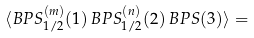<formula> <loc_0><loc_0><loc_500><loc_500>\langle B P S _ { 1 / 2 } ^ { ( m ) } ( 1 ) \, B P S _ { 1 / 2 } ^ { ( n ) } ( 2 ) \, B P S ( 3 ) \rangle =</formula> 